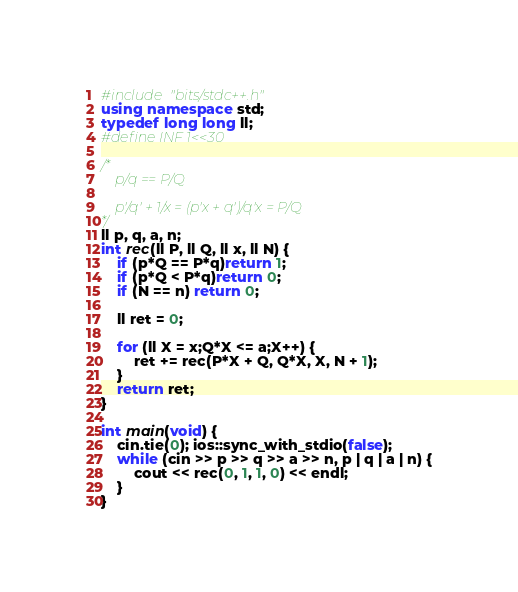<code> <loc_0><loc_0><loc_500><loc_500><_C++_>#include "bits/stdc++.h"
using namespace std;
typedef long long ll;
#define INF 1<<30

/*
	p/q == P/Q

	p'/q' + 1/x = (p'x + q')/q'x = P/Q
*/
ll p, q, a, n;
int rec(ll P, ll Q, ll x, ll N) {
	if (p*Q == P*q)return 1;
	if (p*Q < P*q)return 0;
	if (N == n) return 0;

	ll ret = 0;

	for (ll X = x;Q*X <= a;X++) {
		ret += rec(P*X + Q, Q*X, X, N + 1);
	}
	return ret;
}

int main(void) {
	cin.tie(0); ios::sync_with_stdio(false);
	while (cin >> p >> q >> a >> n, p | q | a | n) {
		cout << rec(0, 1, 1, 0) << endl;
	}
}</code> 